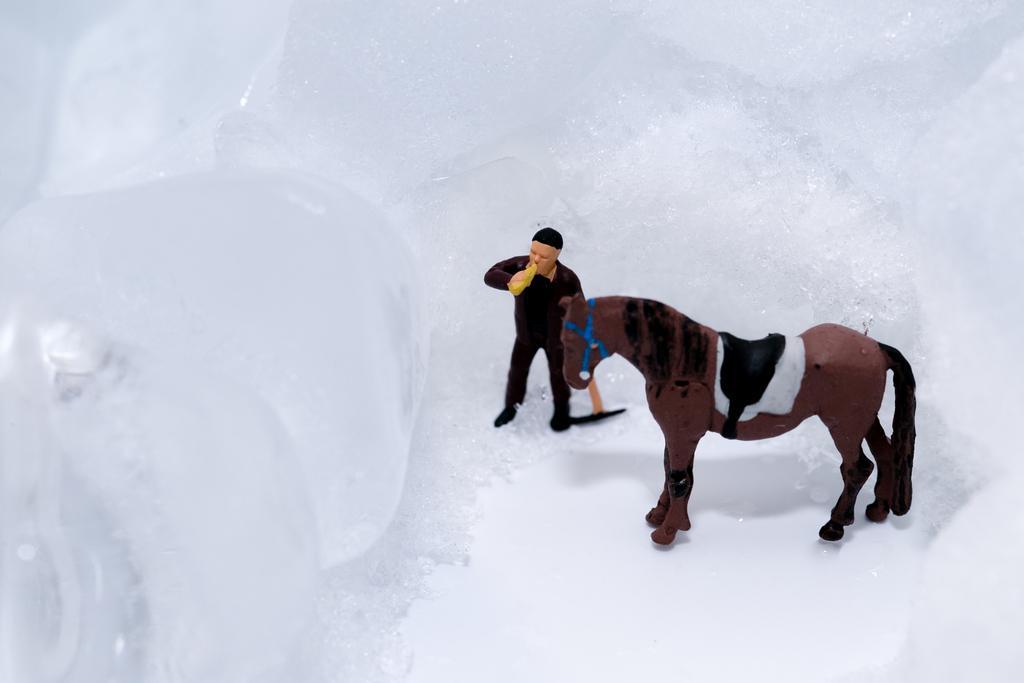How would you summarize this image in a sentence or two? In this image I can see the digital art in which I can see a person wearing black color dress is standing and holding yellow colored object in his hand and a horse which is black, brown and blue in color. I can see the white colored surface. 